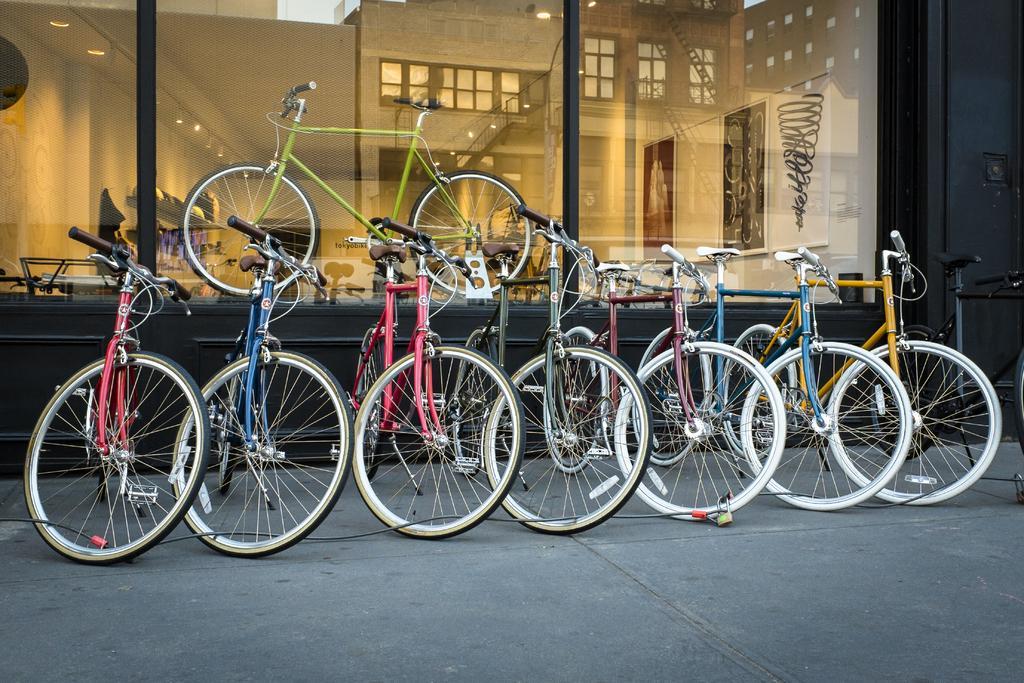Can you describe this image briefly? in this image there are bicycles on the road. In the background there is glass and behind the glass there is a bicycle and there are frames on the wall. On the right side there is a wall which is black in colour and on the glass there is the reflection of the windows. 